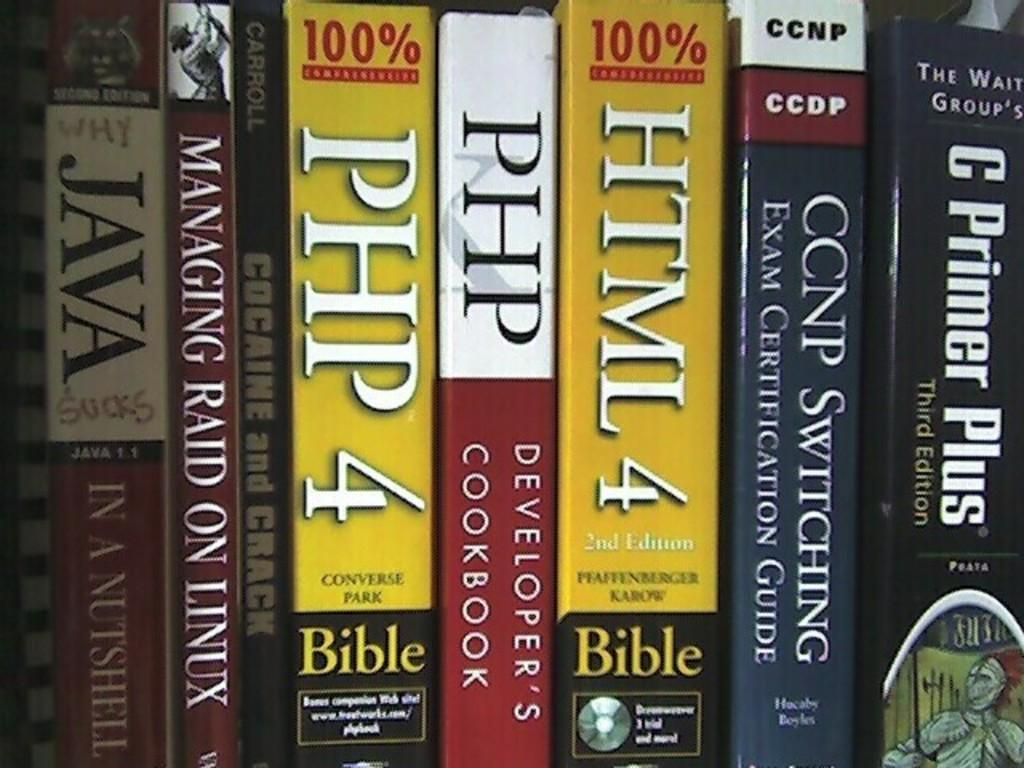<image>
Give a short and clear explanation of the subsequent image. Books placed on a shelf with "HTML 4" being in the middle. 